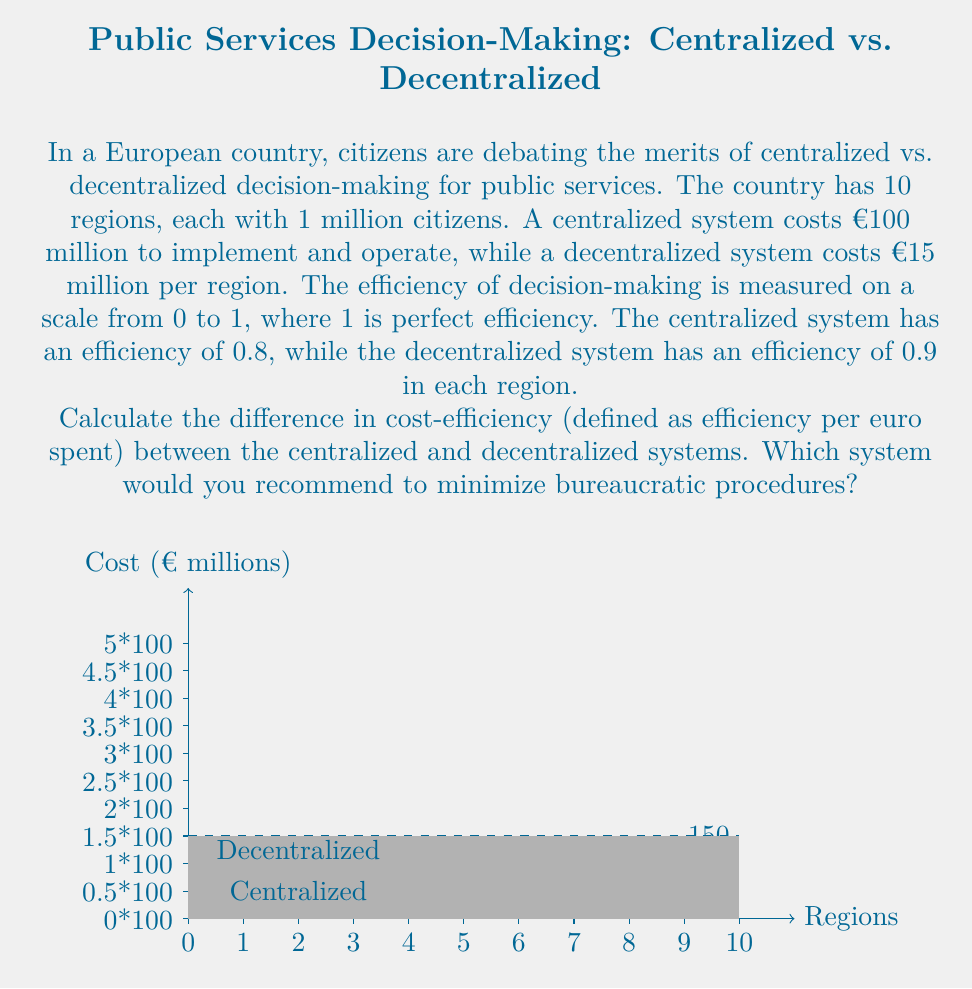Show me your answer to this math problem. Let's approach this step-by-step:

1) First, calculate the total cost for each system:
   Centralized: €100 million
   Decentralized: €15 million × 10 regions = €150 million

2) Now, calculate the total efficiency for each system:
   Centralized: 0.8 (given)
   Decentralized: 0.9 × 10 regions = 9 (sum of efficiencies across all regions)

3) Calculate the cost-efficiency for each system:
   Centralized: $\frac{0.8}{100,000,000} = 8 \times 10^{-9}$ efficiency/euro
   Decentralized: $\frac{9}{150,000,000} = 6 \times 10^{-8}$ efficiency/euro

4) Calculate the difference in cost-efficiency:
   $6 \times 10^{-8} - 8 \times 10^{-9} = 5.2 \times 10^{-8}$ efficiency/euro

5) The decentralized system has a higher cost-efficiency by $5.2 \times 10^{-8}$ efficiency/euro.

6) From the perspective of minimizing bureaucratic procedures:
   The decentralized system allows for more local decision-making, which typically results in less bureaucracy and faster responses to local needs. This aligns with the given persona of being "fundamentally against bureaucratic procedures".

Therefore, the decentralized system would be recommended to minimize bureaucratic procedures, despite its higher total cost. It offers better efficiency and aligns with the desire for less bureaucracy.
Answer: $5.2 \times 10^{-8}$ efficiency/euro difference; recommend decentralized system 